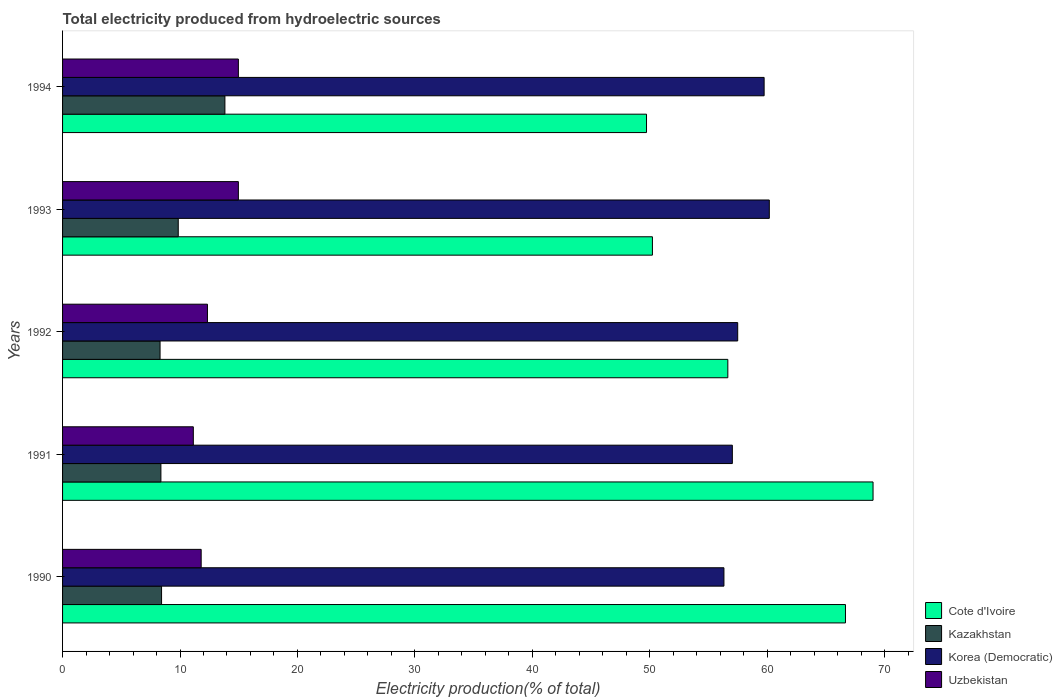Are the number of bars per tick equal to the number of legend labels?
Provide a short and direct response. Yes. Are the number of bars on each tick of the Y-axis equal?
Provide a succinct answer. Yes. How many bars are there on the 2nd tick from the top?
Offer a very short reply. 4. How many bars are there on the 1st tick from the bottom?
Your answer should be compact. 4. What is the total electricity produced in Kazakhstan in 1990?
Your answer should be very brief. 8.43. Across all years, what is the maximum total electricity produced in Kazakhstan?
Your answer should be compact. 13.82. Across all years, what is the minimum total electricity produced in Kazakhstan?
Keep it short and to the point. 8.3. What is the total total electricity produced in Korea (Democratic) in the graph?
Provide a succinct answer. 290.76. What is the difference between the total electricity produced in Korea (Democratic) in 1991 and that in 1992?
Give a very brief answer. -0.46. What is the difference between the total electricity produced in Kazakhstan in 1990 and the total electricity produced in Korea (Democratic) in 1994?
Ensure brevity in your answer.  -51.31. What is the average total electricity produced in Kazakhstan per year?
Make the answer very short. 9.76. In the year 1990, what is the difference between the total electricity produced in Korea (Democratic) and total electricity produced in Kazakhstan?
Offer a very short reply. 47.89. What is the ratio of the total electricity produced in Uzbekistan in 1991 to that in 1994?
Your answer should be compact. 0.74. Is the difference between the total electricity produced in Korea (Democratic) in 1991 and 1994 greater than the difference between the total electricity produced in Kazakhstan in 1991 and 1994?
Keep it short and to the point. Yes. What is the difference between the highest and the second highest total electricity produced in Cote d'Ivoire?
Ensure brevity in your answer.  2.35. What is the difference between the highest and the lowest total electricity produced in Korea (Democratic)?
Ensure brevity in your answer.  3.86. In how many years, is the total electricity produced in Korea (Democratic) greater than the average total electricity produced in Korea (Democratic) taken over all years?
Your response must be concise. 2. Is the sum of the total electricity produced in Korea (Democratic) in 1990 and 1991 greater than the maximum total electricity produced in Kazakhstan across all years?
Ensure brevity in your answer.  Yes. Is it the case that in every year, the sum of the total electricity produced in Cote d'Ivoire and total electricity produced in Uzbekistan is greater than the sum of total electricity produced in Korea (Democratic) and total electricity produced in Kazakhstan?
Your answer should be compact. Yes. What does the 1st bar from the top in 1993 represents?
Your answer should be very brief. Uzbekistan. What does the 3rd bar from the bottom in 1990 represents?
Provide a short and direct response. Korea (Democratic). How many bars are there?
Offer a very short reply. 20. Are all the bars in the graph horizontal?
Make the answer very short. Yes. How many years are there in the graph?
Give a very brief answer. 5. How are the legend labels stacked?
Ensure brevity in your answer.  Vertical. What is the title of the graph?
Keep it short and to the point. Total electricity produced from hydroelectric sources. What is the Electricity production(% of total) of Cote d'Ivoire in 1990?
Ensure brevity in your answer.  66.67. What is the Electricity production(% of total) in Kazakhstan in 1990?
Provide a short and direct response. 8.43. What is the Electricity production(% of total) in Korea (Democratic) in 1990?
Give a very brief answer. 56.32. What is the Electricity production(% of total) in Uzbekistan in 1990?
Offer a very short reply. 11.8. What is the Electricity production(% of total) in Cote d'Ivoire in 1991?
Give a very brief answer. 69.01. What is the Electricity production(% of total) of Kazakhstan in 1991?
Give a very brief answer. 8.37. What is the Electricity production(% of total) in Korea (Democratic) in 1991?
Make the answer very short. 57.03. What is the Electricity production(% of total) in Uzbekistan in 1991?
Offer a terse response. 11.13. What is the Electricity production(% of total) of Cote d'Ivoire in 1992?
Keep it short and to the point. 56.65. What is the Electricity production(% of total) in Kazakhstan in 1992?
Offer a very short reply. 8.3. What is the Electricity production(% of total) in Korea (Democratic) in 1992?
Give a very brief answer. 57.49. What is the Electricity production(% of total) of Uzbekistan in 1992?
Provide a succinct answer. 12.34. What is the Electricity production(% of total) of Cote d'Ivoire in 1993?
Keep it short and to the point. 50.23. What is the Electricity production(% of total) in Kazakhstan in 1993?
Offer a very short reply. 9.85. What is the Electricity production(% of total) in Korea (Democratic) in 1993?
Your answer should be very brief. 60.18. What is the Electricity production(% of total) in Uzbekistan in 1993?
Keep it short and to the point. 14.97. What is the Electricity production(% of total) in Cote d'Ivoire in 1994?
Provide a succinct answer. 49.72. What is the Electricity production(% of total) in Kazakhstan in 1994?
Your answer should be compact. 13.82. What is the Electricity production(% of total) in Korea (Democratic) in 1994?
Give a very brief answer. 59.74. What is the Electricity production(% of total) in Uzbekistan in 1994?
Your answer should be compact. 14.97. Across all years, what is the maximum Electricity production(% of total) in Cote d'Ivoire?
Your response must be concise. 69.01. Across all years, what is the maximum Electricity production(% of total) of Kazakhstan?
Your answer should be very brief. 13.82. Across all years, what is the maximum Electricity production(% of total) of Korea (Democratic)?
Offer a terse response. 60.18. Across all years, what is the maximum Electricity production(% of total) of Uzbekistan?
Your response must be concise. 14.97. Across all years, what is the minimum Electricity production(% of total) of Cote d'Ivoire?
Ensure brevity in your answer.  49.72. Across all years, what is the minimum Electricity production(% of total) of Kazakhstan?
Offer a terse response. 8.3. Across all years, what is the minimum Electricity production(% of total) in Korea (Democratic)?
Offer a very short reply. 56.32. Across all years, what is the minimum Electricity production(% of total) of Uzbekistan?
Provide a succinct answer. 11.13. What is the total Electricity production(% of total) in Cote d'Ivoire in the graph?
Make the answer very short. 292.28. What is the total Electricity production(% of total) of Kazakhstan in the graph?
Your answer should be compact. 48.78. What is the total Electricity production(% of total) of Korea (Democratic) in the graph?
Give a very brief answer. 290.76. What is the total Electricity production(% of total) in Uzbekistan in the graph?
Your response must be concise. 65.22. What is the difference between the Electricity production(% of total) of Cote d'Ivoire in 1990 and that in 1991?
Give a very brief answer. -2.35. What is the difference between the Electricity production(% of total) of Kazakhstan in 1990 and that in 1991?
Provide a succinct answer. 0.06. What is the difference between the Electricity production(% of total) in Korea (Democratic) in 1990 and that in 1991?
Provide a short and direct response. -0.72. What is the difference between the Electricity production(% of total) in Uzbekistan in 1990 and that in 1991?
Provide a short and direct response. 0.67. What is the difference between the Electricity production(% of total) in Cote d'Ivoire in 1990 and that in 1992?
Offer a terse response. 10.02. What is the difference between the Electricity production(% of total) of Kazakhstan in 1990 and that in 1992?
Your answer should be very brief. 0.13. What is the difference between the Electricity production(% of total) of Korea (Democratic) in 1990 and that in 1992?
Make the answer very short. -1.17. What is the difference between the Electricity production(% of total) in Uzbekistan in 1990 and that in 1992?
Your answer should be compact. -0.53. What is the difference between the Electricity production(% of total) of Cote d'Ivoire in 1990 and that in 1993?
Offer a terse response. 16.44. What is the difference between the Electricity production(% of total) in Kazakhstan in 1990 and that in 1993?
Make the answer very short. -1.42. What is the difference between the Electricity production(% of total) in Korea (Democratic) in 1990 and that in 1993?
Make the answer very short. -3.86. What is the difference between the Electricity production(% of total) of Uzbekistan in 1990 and that in 1993?
Provide a succinct answer. -3.17. What is the difference between the Electricity production(% of total) of Cote d'Ivoire in 1990 and that in 1994?
Your answer should be compact. 16.94. What is the difference between the Electricity production(% of total) of Kazakhstan in 1990 and that in 1994?
Provide a succinct answer. -5.39. What is the difference between the Electricity production(% of total) of Korea (Democratic) in 1990 and that in 1994?
Make the answer very short. -3.42. What is the difference between the Electricity production(% of total) of Uzbekistan in 1990 and that in 1994?
Your answer should be compact. -3.17. What is the difference between the Electricity production(% of total) in Cote d'Ivoire in 1991 and that in 1992?
Your answer should be very brief. 12.37. What is the difference between the Electricity production(% of total) in Kazakhstan in 1991 and that in 1992?
Make the answer very short. 0.07. What is the difference between the Electricity production(% of total) of Korea (Democratic) in 1991 and that in 1992?
Give a very brief answer. -0.46. What is the difference between the Electricity production(% of total) of Uzbekistan in 1991 and that in 1992?
Make the answer very short. -1.2. What is the difference between the Electricity production(% of total) in Cote d'Ivoire in 1991 and that in 1993?
Give a very brief answer. 18.79. What is the difference between the Electricity production(% of total) of Kazakhstan in 1991 and that in 1993?
Your response must be concise. -1.48. What is the difference between the Electricity production(% of total) of Korea (Democratic) in 1991 and that in 1993?
Your answer should be very brief. -3.15. What is the difference between the Electricity production(% of total) in Uzbekistan in 1991 and that in 1993?
Make the answer very short. -3.84. What is the difference between the Electricity production(% of total) in Cote d'Ivoire in 1991 and that in 1994?
Your answer should be very brief. 19.29. What is the difference between the Electricity production(% of total) in Kazakhstan in 1991 and that in 1994?
Provide a short and direct response. -5.45. What is the difference between the Electricity production(% of total) of Korea (Democratic) in 1991 and that in 1994?
Your response must be concise. -2.71. What is the difference between the Electricity production(% of total) of Uzbekistan in 1991 and that in 1994?
Offer a terse response. -3.84. What is the difference between the Electricity production(% of total) of Cote d'Ivoire in 1992 and that in 1993?
Your answer should be very brief. 6.42. What is the difference between the Electricity production(% of total) of Kazakhstan in 1992 and that in 1993?
Offer a very short reply. -1.55. What is the difference between the Electricity production(% of total) of Korea (Democratic) in 1992 and that in 1993?
Your answer should be very brief. -2.69. What is the difference between the Electricity production(% of total) in Uzbekistan in 1992 and that in 1993?
Your answer should be compact. -2.63. What is the difference between the Electricity production(% of total) of Cote d'Ivoire in 1992 and that in 1994?
Ensure brevity in your answer.  6.92. What is the difference between the Electricity production(% of total) in Kazakhstan in 1992 and that in 1994?
Make the answer very short. -5.52. What is the difference between the Electricity production(% of total) of Korea (Democratic) in 1992 and that in 1994?
Give a very brief answer. -2.25. What is the difference between the Electricity production(% of total) in Uzbekistan in 1992 and that in 1994?
Provide a short and direct response. -2.63. What is the difference between the Electricity production(% of total) of Cote d'Ivoire in 1993 and that in 1994?
Make the answer very short. 0.5. What is the difference between the Electricity production(% of total) in Kazakhstan in 1993 and that in 1994?
Keep it short and to the point. -3.97. What is the difference between the Electricity production(% of total) of Korea (Democratic) in 1993 and that in 1994?
Provide a short and direct response. 0.44. What is the difference between the Electricity production(% of total) of Cote d'Ivoire in 1990 and the Electricity production(% of total) of Kazakhstan in 1991?
Provide a short and direct response. 58.29. What is the difference between the Electricity production(% of total) of Cote d'Ivoire in 1990 and the Electricity production(% of total) of Korea (Democratic) in 1991?
Provide a succinct answer. 9.63. What is the difference between the Electricity production(% of total) in Cote d'Ivoire in 1990 and the Electricity production(% of total) in Uzbekistan in 1991?
Your answer should be very brief. 55.53. What is the difference between the Electricity production(% of total) in Kazakhstan in 1990 and the Electricity production(% of total) in Korea (Democratic) in 1991?
Provide a succinct answer. -48.6. What is the difference between the Electricity production(% of total) in Kazakhstan in 1990 and the Electricity production(% of total) in Uzbekistan in 1991?
Your answer should be very brief. -2.7. What is the difference between the Electricity production(% of total) in Korea (Democratic) in 1990 and the Electricity production(% of total) in Uzbekistan in 1991?
Provide a short and direct response. 45.18. What is the difference between the Electricity production(% of total) in Cote d'Ivoire in 1990 and the Electricity production(% of total) in Kazakhstan in 1992?
Give a very brief answer. 58.36. What is the difference between the Electricity production(% of total) in Cote d'Ivoire in 1990 and the Electricity production(% of total) in Korea (Democratic) in 1992?
Your response must be concise. 9.18. What is the difference between the Electricity production(% of total) in Cote d'Ivoire in 1990 and the Electricity production(% of total) in Uzbekistan in 1992?
Ensure brevity in your answer.  54.33. What is the difference between the Electricity production(% of total) in Kazakhstan in 1990 and the Electricity production(% of total) in Korea (Democratic) in 1992?
Offer a very short reply. -49.06. What is the difference between the Electricity production(% of total) in Kazakhstan in 1990 and the Electricity production(% of total) in Uzbekistan in 1992?
Your response must be concise. -3.91. What is the difference between the Electricity production(% of total) in Korea (Democratic) in 1990 and the Electricity production(% of total) in Uzbekistan in 1992?
Ensure brevity in your answer.  43.98. What is the difference between the Electricity production(% of total) in Cote d'Ivoire in 1990 and the Electricity production(% of total) in Kazakhstan in 1993?
Provide a succinct answer. 56.82. What is the difference between the Electricity production(% of total) in Cote d'Ivoire in 1990 and the Electricity production(% of total) in Korea (Democratic) in 1993?
Provide a short and direct response. 6.49. What is the difference between the Electricity production(% of total) of Cote d'Ivoire in 1990 and the Electricity production(% of total) of Uzbekistan in 1993?
Your response must be concise. 51.7. What is the difference between the Electricity production(% of total) in Kazakhstan in 1990 and the Electricity production(% of total) in Korea (Democratic) in 1993?
Offer a terse response. -51.75. What is the difference between the Electricity production(% of total) in Kazakhstan in 1990 and the Electricity production(% of total) in Uzbekistan in 1993?
Provide a short and direct response. -6.54. What is the difference between the Electricity production(% of total) in Korea (Democratic) in 1990 and the Electricity production(% of total) in Uzbekistan in 1993?
Your response must be concise. 41.35. What is the difference between the Electricity production(% of total) of Cote d'Ivoire in 1990 and the Electricity production(% of total) of Kazakhstan in 1994?
Provide a succinct answer. 52.84. What is the difference between the Electricity production(% of total) of Cote d'Ivoire in 1990 and the Electricity production(% of total) of Korea (Democratic) in 1994?
Your answer should be very brief. 6.93. What is the difference between the Electricity production(% of total) of Cote d'Ivoire in 1990 and the Electricity production(% of total) of Uzbekistan in 1994?
Your response must be concise. 51.7. What is the difference between the Electricity production(% of total) in Kazakhstan in 1990 and the Electricity production(% of total) in Korea (Democratic) in 1994?
Make the answer very short. -51.31. What is the difference between the Electricity production(% of total) of Kazakhstan in 1990 and the Electricity production(% of total) of Uzbekistan in 1994?
Provide a short and direct response. -6.54. What is the difference between the Electricity production(% of total) in Korea (Democratic) in 1990 and the Electricity production(% of total) in Uzbekistan in 1994?
Keep it short and to the point. 41.35. What is the difference between the Electricity production(% of total) in Cote d'Ivoire in 1991 and the Electricity production(% of total) in Kazakhstan in 1992?
Make the answer very short. 60.71. What is the difference between the Electricity production(% of total) of Cote d'Ivoire in 1991 and the Electricity production(% of total) of Korea (Democratic) in 1992?
Give a very brief answer. 11.53. What is the difference between the Electricity production(% of total) of Cote d'Ivoire in 1991 and the Electricity production(% of total) of Uzbekistan in 1992?
Offer a very short reply. 56.68. What is the difference between the Electricity production(% of total) of Kazakhstan in 1991 and the Electricity production(% of total) of Korea (Democratic) in 1992?
Offer a terse response. -49.12. What is the difference between the Electricity production(% of total) of Kazakhstan in 1991 and the Electricity production(% of total) of Uzbekistan in 1992?
Offer a terse response. -3.96. What is the difference between the Electricity production(% of total) in Korea (Democratic) in 1991 and the Electricity production(% of total) in Uzbekistan in 1992?
Keep it short and to the point. 44.7. What is the difference between the Electricity production(% of total) in Cote d'Ivoire in 1991 and the Electricity production(% of total) in Kazakhstan in 1993?
Make the answer very short. 59.16. What is the difference between the Electricity production(% of total) in Cote d'Ivoire in 1991 and the Electricity production(% of total) in Korea (Democratic) in 1993?
Provide a short and direct response. 8.83. What is the difference between the Electricity production(% of total) of Cote d'Ivoire in 1991 and the Electricity production(% of total) of Uzbekistan in 1993?
Make the answer very short. 54.04. What is the difference between the Electricity production(% of total) in Kazakhstan in 1991 and the Electricity production(% of total) in Korea (Democratic) in 1993?
Your answer should be very brief. -51.81. What is the difference between the Electricity production(% of total) of Kazakhstan in 1991 and the Electricity production(% of total) of Uzbekistan in 1993?
Offer a very short reply. -6.6. What is the difference between the Electricity production(% of total) in Korea (Democratic) in 1991 and the Electricity production(% of total) in Uzbekistan in 1993?
Offer a very short reply. 42.06. What is the difference between the Electricity production(% of total) in Cote d'Ivoire in 1991 and the Electricity production(% of total) in Kazakhstan in 1994?
Your answer should be compact. 55.19. What is the difference between the Electricity production(% of total) of Cote d'Ivoire in 1991 and the Electricity production(% of total) of Korea (Democratic) in 1994?
Ensure brevity in your answer.  9.27. What is the difference between the Electricity production(% of total) of Cote d'Ivoire in 1991 and the Electricity production(% of total) of Uzbekistan in 1994?
Your answer should be very brief. 54.04. What is the difference between the Electricity production(% of total) of Kazakhstan in 1991 and the Electricity production(% of total) of Korea (Democratic) in 1994?
Keep it short and to the point. -51.37. What is the difference between the Electricity production(% of total) of Kazakhstan in 1991 and the Electricity production(% of total) of Uzbekistan in 1994?
Provide a short and direct response. -6.6. What is the difference between the Electricity production(% of total) of Korea (Democratic) in 1991 and the Electricity production(% of total) of Uzbekistan in 1994?
Give a very brief answer. 42.06. What is the difference between the Electricity production(% of total) of Cote d'Ivoire in 1992 and the Electricity production(% of total) of Kazakhstan in 1993?
Your response must be concise. 46.8. What is the difference between the Electricity production(% of total) of Cote d'Ivoire in 1992 and the Electricity production(% of total) of Korea (Democratic) in 1993?
Your response must be concise. -3.53. What is the difference between the Electricity production(% of total) of Cote d'Ivoire in 1992 and the Electricity production(% of total) of Uzbekistan in 1993?
Make the answer very short. 41.68. What is the difference between the Electricity production(% of total) of Kazakhstan in 1992 and the Electricity production(% of total) of Korea (Democratic) in 1993?
Provide a short and direct response. -51.88. What is the difference between the Electricity production(% of total) of Kazakhstan in 1992 and the Electricity production(% of total) of Uzbekistan in 1993?
Offer a very short reply. -6.67. What is the difference between the Electricity production(% of total) of Korea (Democratic) in 1992 and the Electricity production(% of total) of Uzbekistan in 1993?
Your answer should be very brief. 42.52. What is the difference between the Electricity production(% of total) of Cote d'Ivoire in 1992 and the Electricity production(% of total) of Kazakhstan in 1994?
Your response must be concise. 42.82. What is the difference between the Electricity production(% of total) of Cote d'Ivoire in 1992 and the Electricity production(% of total) of Korea (Democratic) in 1994?
Keep it short and to the point. -3.09. What is the difference between the Electricity production(% of total) in Cote d'Ivoire in 1992 and the Electricity production(% of total) in Uzbekistan in 1994?
Provide a short and direct response. 41.68. What is the difference between the Electricity production(% of total) in Kazakhstan in 1992 and the Electricity production(% of total) in Korea (Democratic) in 1994?
Give a very brief answer. -51.44. What is the difference between the Electricity production(% of total) in Kazakhstan in 1992 and the Electricity production(% of total) in Uzbekistan in 1994?
Your answer should be compact. -6.67. What is the difference between the Electricity production(% of total) of Korea (Democratic) in 1992 and the Electricity production(% of total) of Uzbekistan in 1994?
Make the answer very short. 42.52. What is the difference between the Electricity production(% of total) of Cote d'Ivoire in 1993 and the Electricity production(% of total) of Kazakhstan in 1994?
Offer a very short reply. 36.4. What is the difference between the Electricity production(% of total) of Cote d'Ivoire in 1993 and the Electricity production(% of total) of Korea (Democratic) in 1994?
Make the answer very short. -9.51. What is the difference between the Electricity production(% of total) of Cote d'Ivoire in 1993 and the Electricity production(% of total) of Uzbekistan in 1994?
Offer a very short reply. 35.26. What is the difference between the Electricity production(% of total) of Kazakhstan in 1993 and the Electricity production(% of total) of Korea (Democratic) in 1994?
Offer a terse response. -49.89. What is the difference between the Electricity production(% of total) in Kazakhstan in 1993 and the Electricity production(% of total) in Uzbekistan in 1994?
Ensure brevity in your answer.  -5.12. What is the difference between the Electricity production(% of total) in Korea (Democratic) in 1993 and the Electricity production(% of total) in Uzbekistan in 1994?
Offer a terse response. 45.21. What is the average Electricity production(% of total) in Cote d'Ivoire per year?
Make the answer very short. 58.46. What is the average Electricity production(% of total) of Kazakhstan per year?
Give a very brief answer. 9.76. What is the average Electricity production(% of total) in Korea (Democratic) per year?
Provide a succinct answer. 58.15. What is the average Electricity production(% of total) of Uzbekistan per year?
Your response must be concise. 13.04. In the year 1990, what is the difference between the Electricity production(% of total) of Cote d'Ivoire and Electricity production(% of total) of Kazakhstan?
Provide a succinct answer. 58.24. In the year 1990, what is the difference between the Electricity production(% of total) of Cote d'Ivoire and Electricity production(% of total) of Korea (Democratic)?
Make the answer very short. 10.35. In the year 1990, what is the difference between the Electricity production(% of total) of Cote d'Ivoire and Electricity production(% of total) of Uzbekistan?
Give a very brief answer. 54.86. In the year 1990, what is the difference between the Electricity production(% of total) of Kazakhstan and Electricity production(% of total) of Korea (Democratic)?
Ensure brevity in your answer.  -47.89. In the year 1990, what is the difference between the Electricity production(% of total) of Kazakhstan and Electricity production(% of total) of Uzbekistan?
Keep it short and to the point. -3.37. In the year 1990, what is the difference between the Electricity production(% of total) in Korea (Democratic) and Electricity production(% of total) in Uzbekistan?
Provide a succinct answer. 44.51. In the year 1991, what is the difference between the Electricity production(% of total) in Cote d'Ivoire and Electricity production(% of total) in Kazakhstan?
Your response must be concise. 60.64. In the year 1991, what is the difference between the Electricity production(% of total) of Cote d'Ivoire and Electricity production(% of total) of Korea (Democratic)?
Make the answer very short. 11.98. In the year 1991, what is the difference between the Electricity production(% of total) in Cote d'Ivoire and Electricity production(% of total) in Uzbekistan?
Make the answer very short. 57.88. In the year 1991, what is the difference between the Electricity production(% of total) of Kazakhstan and Electricity production(% of total) of Korea (Democratic)?
Make the answer very short. -48.66. In the year 1991, what is the difference between the Electricity production(% of total) in Kazakhstan and Electricity production(% of total) in Uzbekistan?
Offer a very short reply. -2.76. In the year 1991, what is the difference between the Electricity production(% of total) in Korea (Democratic) and Electricity production(% of total) in Uzbekistan?
Offer a terse response. 45.9. In the year 1992, what is the difference between the Electricity production(% of total) of Cote d'Ivoire and Electricity production(% of total) of Kazakhstan?
Offer a very short reply. 48.35. In the year 1992, what is the difference between the Electricity production(% of total) in Cote d'Ivoire and Electricity production(% of total) in Korea (Democratic)?
Keep it short and to the point. -0.84. In the year 1992, what is the difference between the Electricity production(% of total) in Cote d'Ivoire and Electricity production(% of total) in Uzbekistan?
Give a very brief answer. 44.31. In the year 1992, what is the difference between the Electricity production(% of total) in Kazakhstan and Electricity production(% of total) in Korea (Democratic)?
Provide a succinct answer. -49.19. In the year 1992, what is the difference between the Electricity production(% of total) of Kazakhstan and Electricity production(% of total) of Uzbekistan?
Keep it short and to the point. -4.04. In the year 1992, what is the difference between the Electricity production(% of total) of Korea (Democratic) and Electricity production(% of total) of Uzbekistan?
Provide a short and direct response. 45.15. In the year 1993, what is the difference between the Electricity production(% of total) in Cote d'Ivoire and Electricity production(% of total) in Kazakhstan?
Give a very brief answer. 40.38. In the year 1993, what is the difference between the Electricity production(% of total) in Cote d'Ivoire and Electricity production(% of total) in Korea (Democratic)?
Offer a terse response. -9.95. In the year 1993, what is the difference between the Electricity production(% of total) in Cote d'Ivoire and Electricity production(% of total) in Uzbekistan?
Your answer should be compact. 35.26. In the year 1993, what is the difference between the Electricity production(% of total) of Kazakhstan and Electricity production(% of total) of Korea (Democratic)?
Offer a very short reply. -50.33. In the year 1993, what is the difference between the Electricity production(% of total) in Kazakhstan and Electricity production(% of total) in Uzbekistan?
Provide a short and direct response. -5.12. In the year 1993, what is the difference between the Electricity production(% of total) in Korea (Democratic) and Electricity production(% of total) in Uzbekistan?
Your answer should be compact. 45.21. In the year 1994, what is the difference between the Electricity production(% of total) in Cote d'Ivoire and Electricity production(% of total) in Kazakhstan?
Your response must be concise. 35.9. In the year 1994, what is the difference between the Electricity production(% of total) of Cote d'Ivoire and Electricity production(% of total) of Korea (Democratic)?
Your answer should be compact. -10.02. In the year 1994, what is the difference between the Electricity production(% of total) in Cote d'Ivoire and Electricity production(% of total) in Uzbekistan?
Offer a very short reply. 34.75. In the year 1994, what is the difference between the Electricity production(% of total) of Kazakhstan and Electricity production(% of total) of Korea (Democratic)?
Make the answer very short. -45.92. In the year 1994, what is the difference between the Electricity production(% of total) of Kazakhstan and Electricity production(% of total) of Uzbekistan?
Your answer should be very brief. -1.15. In the year 1994, what is the difference between the Electricity production(% of total) of Korea (Democratic) and Electricity production(% of total) of Uzbekistan?
Give a very brief answer. 44.77. What is the ratio of the Electricity production(% of total) of Cote d'Ivoire in 1990 to that in 1991?
Keep it short and to the point. 0.97. What is the ratio of the Electricity production(% of total) in Korea (Democratic) in 1990 to that in 1991?
Your answer should be compact. 0.99. What is the ratio of the Electricity production(% of total) in Uzbekistan in 1990 to that in 1991?
Offer a terse response. 1.06. What is the ratio of the Electricity production(% of total) of Cote d'Ivoire in 1990 to that in 1992?
Make the answer very short. 1.18. What is the ratio of the Electricity production(% of total) in Kazakhstan in 1990 to that in 1992?
Keep it short and to the point. 1.02. What is the ratio of the Electricity production(% of total) in Korea (Democratic) in 1990 to that in 1992?
Provide a succinct answer. 0.98. What is the ratio of the Electricity production(% of total) in Uzbekistan in 1990 to that in 1992?
Make the answer very short. 0.96. What is the ratio of the Electricity production(% of total) in Cote d'Ivoire in 1990 to that in 1993?
Offer a very short reply. 1.33. What is the ratio of the Electricity production(% of total) in Kazakhstan in 1990 to that in 1993?
Offer a very short reply. 0.86. What is the ratio of the Electricity production(% of total) in Korea (Democratic) in 1990 to that in 1993?
Your answer should be very brief. 0.94. What is the ratio of the Electricity production(% of total) in Uzbekistan in 1990 to that in 1993?
Make the answer very short. 0.79. What is the ratio of the Electricity production(% of total) in Cote d'Ivoire in 1990 to that in 1994?
Your answer should be very brief. 1.34. What is the ratio of the Electricity production(% of total) of Kazakhstan in 1990 to that in 1994?
Provide a succinct answer. 0.61. What is the ratio of the Electricity production(% of total) in Korea (Democratic) in 1990 to that in 1994?
Ensure brevity in your answer.  0.94. What is the ratio of the Electricity production(% of total) of Uzbekistan in 1990 to that in 1994?
Make the answer very short. 0.79. What is the ratio of the Electricity production(% of total) in Cote d'Ivoire in 1991 to that in 1992?
Ensure brevity in your answer.  1.22. What is the ratio of the Electricity production(% of total) in Kazakhstan in 1991 to that in 1992?
Offer a terse response. 1.01. What is the ratio of the Electricity production(% of total) in Korea (Democratic) in 1991 to that in 1992?
Make the answer very short. 0.99. What is the ratio of the Electricity production(% of total) of Uzbekistan in 1991 to that in 1992?
Your response must be concise. 0.9. What is the ratio of the Electricity production(% of total) in Cote d'Ivoire in 1991 to that in 1993?
Your answer should be very brief. 1.37. What is the ratio of the Electricity production(% of total) in Kazakhstan in 1991 to that in 1993?
Provide a succinct answer. 0.85. What is the ratio of the Electricity production(% of total) in Korea (Democratic) in 1991 to that in 1993?
Offer a terse response. 0.95. What is the ratio of the Electricity production(% of total) of Uzbekistan in 1991 to that in 1993?
Keep it short and to the point. 0.74. What is the ratio of the Electricity production(% of total) of Cote d'Ivoire in 1991 to that in 1994?
Provide a succinct answer. 1.39. What is the ratio of the Electricity production(% of total) of Kazakhstan in 1991 to that in 1994?
Provide a short and direct response. 0.61. What is the ratio of the Electricity production(% of total) of Korea (Democratic) in 1991 to that in 1994?
Provide a succinct answer. 0.95. What is the ratio of the Electricity production(% of total) in Uzbekistan in 1991 to that in 1994?
Your response must be concise. 0.74. What is the ratio of the Electricity production(% of total) of Cote d'Ivoire in 1992 to that in 1993?
Your response must be concise. 1.13. What is the ratio of the Electricity production(% of total) of Kazakhstan in 1992 to that in 1993?
Make the answer very short. 0.84. What is the ratio of the Electricity production(% of total) of Korea (Democratic) in 1992 to that in 1993?
Keep it short and to the point. 0.96. What is the ratio of the Electricity production(% of total) of Uzbekistan in 1992 to that in 1993?
Provide a short and direct response. 0.82. What is the ratio of the Electricity production(% of total) of Cote d'Ivoire in 1992 to that in 1994?
Provide a succinct answer. 1.14. What is the ratio of the Electricity production(% of total) in Kazakhstan in 1992 to that in 1994?
Provide a short and direct response. 0.6. What is the ratio of the Electricity production(% of total) in Korea (Democratic) in 1992 to that in 1994?
Keep it short and to the point. 0.96. What is the ratio of the Electricity production(% of total) of Uzbekistan in 1992 to that in 1994?
Make the answer very short. 0.82. What is the ratio of the Electricity production(% of total) in Cote d'Ivoire in 1993 to that in 1994?
Ensure brevity in your answer.  1.01. What is the ratio of the Electricity production(% of total) of Kazakhstan in 1993 to that in 1994?
Provide a succinct answer. 0.71. What is the ratio of the Electricity production(% of total) in Korea (Democratic) in 1993 to that in 1994?
Offer a very short reply. 1.01. What is the difference between the highest and the second highest Electricity production(% of total) of Cote d'Ivoire?
Make the answer very short. 2.35. What is the difference between the highest and the second highest Electricity production(% of total) in Kazakhstan?
Ensure brevity in your answer.  3.97. What is the difference between the highest and the second highest Electricity production(% of total) of Korea (Democratic)?
Offer a very short reply. 0.44. What is the difference between the highest and the second highest Electricity production(% of total) of Uzbekistan?
Give a very brief answer. 0. What is the difference between the highest and the lowest Electricity production(% of total) of Cote d'Ivoire?
Offer a very short reply. 19.29. What is the difference between the highest and the lowest Electricity production(% of total) in Kazakhstan?
Provide a short and direct response. 5.52. What is the difference between the highest and the lowest Electricity production(% of total) in Korea (Democratic)?
Offer a very short reply. 3.86. What is the difference between the highest and the lowest Electricity production(% of total) in Uzbekistan?
Ensure brevity in your answer.  3.84. 